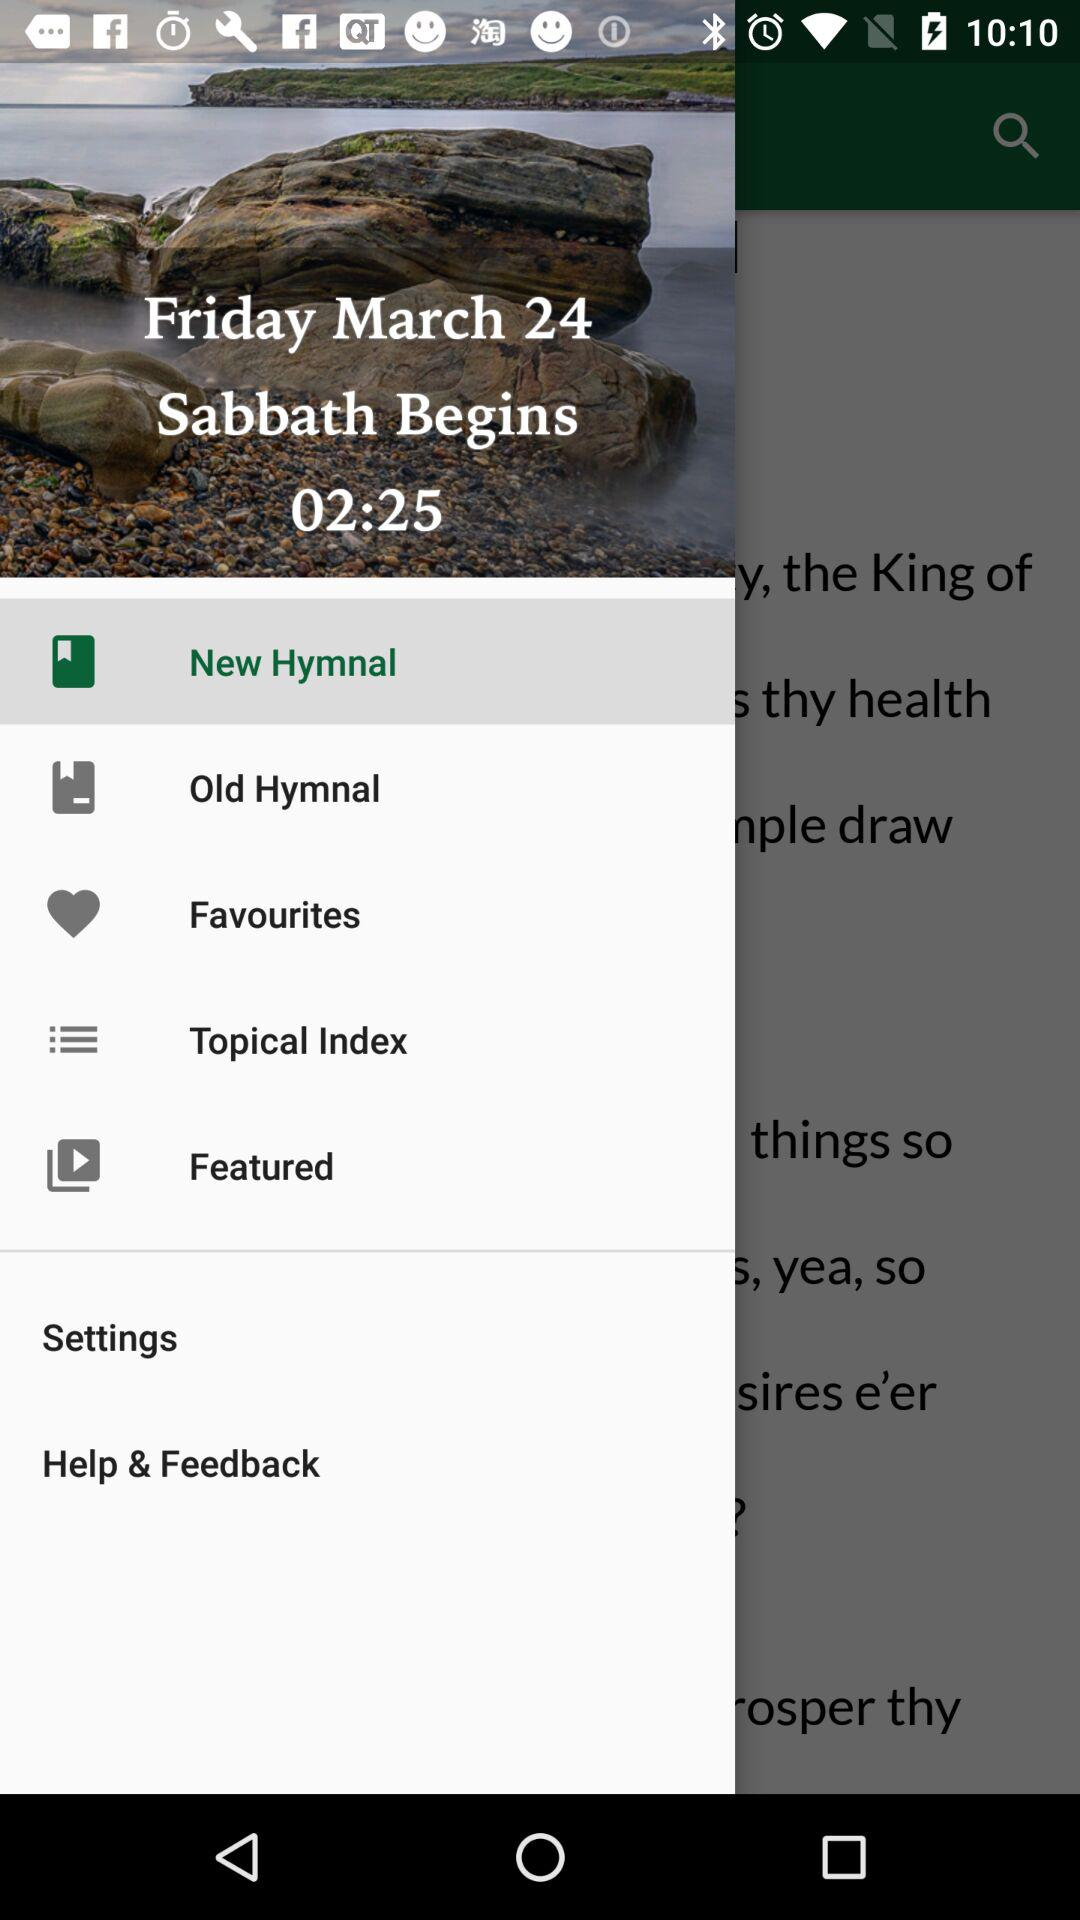What is the date on which the Sabbath begins? The date is Friday, March 24. 